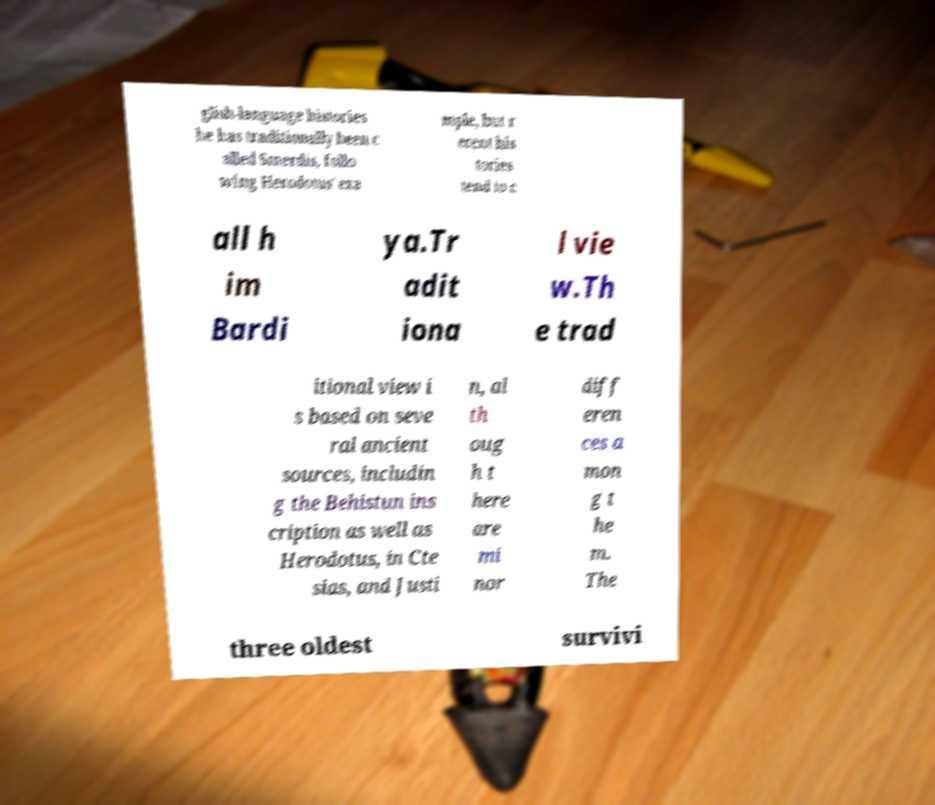Please read and relay the text visible in this image. What does it say? glish-language histories he has traditionally been c alled Smerdis, follo wing Herodotus' exa mple, but r ecent his tories tend to c all h im Bardi ya.Tr adit iona l vie w.Th e trad itional view i s based on seve ral ancient sources, includin g the Behistun ins cription as well as Herodotus, in Cte sias, and Justi n, al th oug h t here are mi nor diff eren ces a mon g t he m. The three oldest survivi 